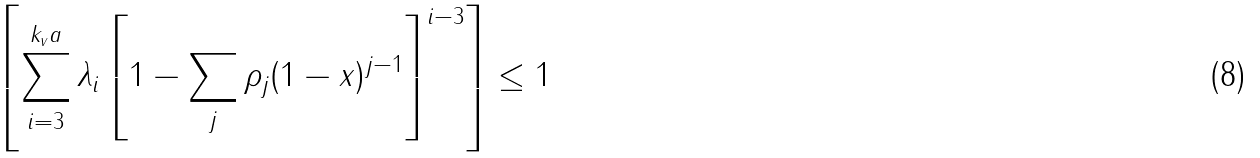Convert formula to latex. <formula><loc_0><loc_0><loc_500><loc_500>\left [ \sum _ { i = 3 } ^ { k _ { v } a } \lambda _ { i } \left [ 1 - \sum _ { j } \rho _ { j } ( 1 - x ) ^ { j - 1 } \right ] ^ { i - 3 } \right ] \leq 1</formula> 